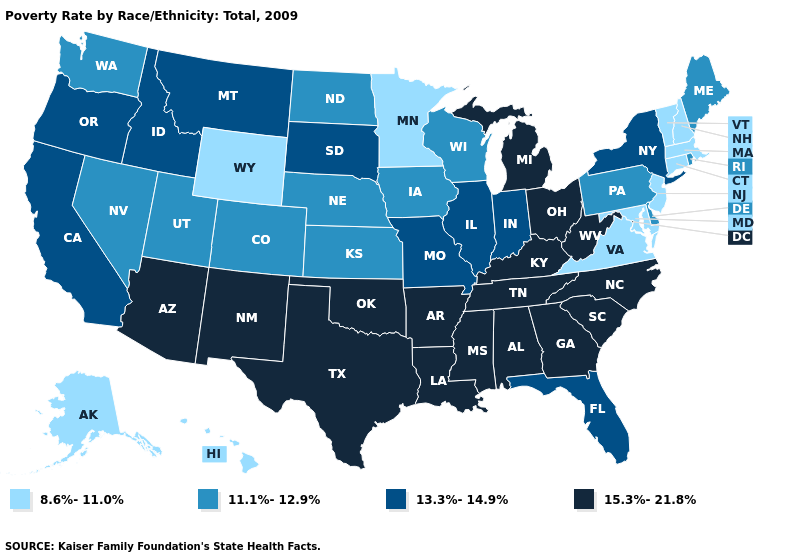Among the states that border New Jersey , does New York have the lowest value?
Quick response, please. No. What is the highest value in states that border Colorado?
Concise answer only. 15.3%-21.8%. What is the highest value in the USA?
Answer briefly. 15.3%-21.8%. Does Massachusetts have the highest value in the Northeast?
Give a very brief answer. No. Name the states that have a value in the range 13.3%-14.9%?
Keep it brief. California, Florida, Idaho, Illinois, Indiana, Missouri, Montana, New York, Oregon, South Dakota. Name the states that have a value in the range 8.6%-11.0%?
Answer briefly. Alaska, Connecticut, Hawaii, Maryland, Massachusetts, Minnesota, New Hampshire, New Jersey, Vermont, Virginia, Wyoming. What is the value of New Mexico?
Quick response, please. 15.3%-21.8%. Which states have the lowest value in the USA?
Quick response, please. Alaska, Connecticut, Hawaii, Maryland, Massachusetts, Minnesota, New Hampshire, New Jersey, Vermont, Virginia, Wyoming. Which states hav the highest value in the South?
Write a very short answer. Alabama, Arkansas, Georgia, Kentucky, Louisiana, Mississippi, North Carolina, Oklahoma, South Carolina, Tennessee, Texas, West Virginia. Among the states that border Michigan , which have the lowest value?
Keep it brief. Wisconsin. Which states have the highest value in the USA?
Give a very brief answer. Alabama, Arizona, Arkansas, Georgia, Kentucky, Louisiana, Michigan, Mississippi, New Mexico, North Carolina, Ohio, Oklahoma, South Carolina, Tennessee, Texas, West Virginia. Does the map have missing data?
Concise answer only. No. Which states have the lowest value in the West?
Keep it brief. Alaska, Hawaii, Wyoming. Does West Virginia have a lower value than Indiana?
Be succinct. No. Among the states that border Ohio , does West Virginia have the highest value?
Concise answer only. Yes. 